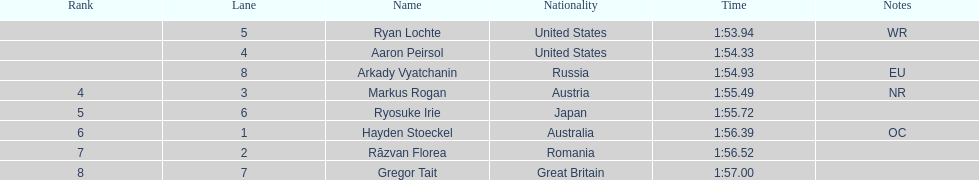Can you count the names that are listed? 8. 